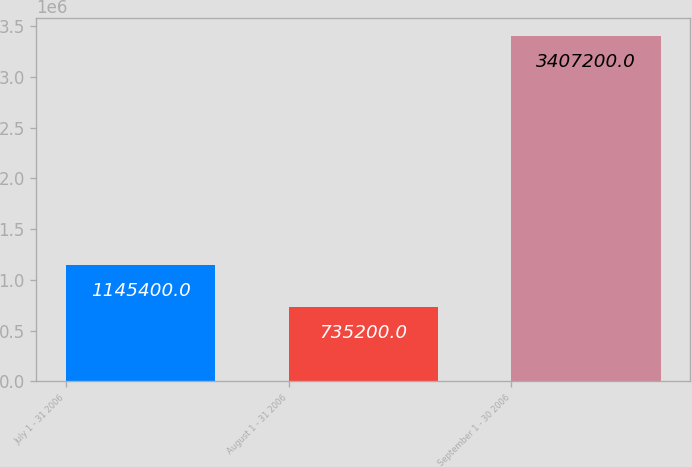Convert chart to OTSL. <chart><loc_0><loc_0><loc_500><loc_500><bar_chart><fcel>July 1 - 31 2006<fcel>August 1 - 31 2006<fcel>September 1 - 30 2006<nl><fcel>1.1454e+06<fcel>735200<fcel>3.4072e+06<nl></chart> 